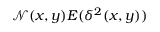<formula> <loc_0><loc_0><loc_500><loc_500>\mathcal { N } ( x , y ) E ( \delta ^ { 2 } ( x , y ) )</formula> 